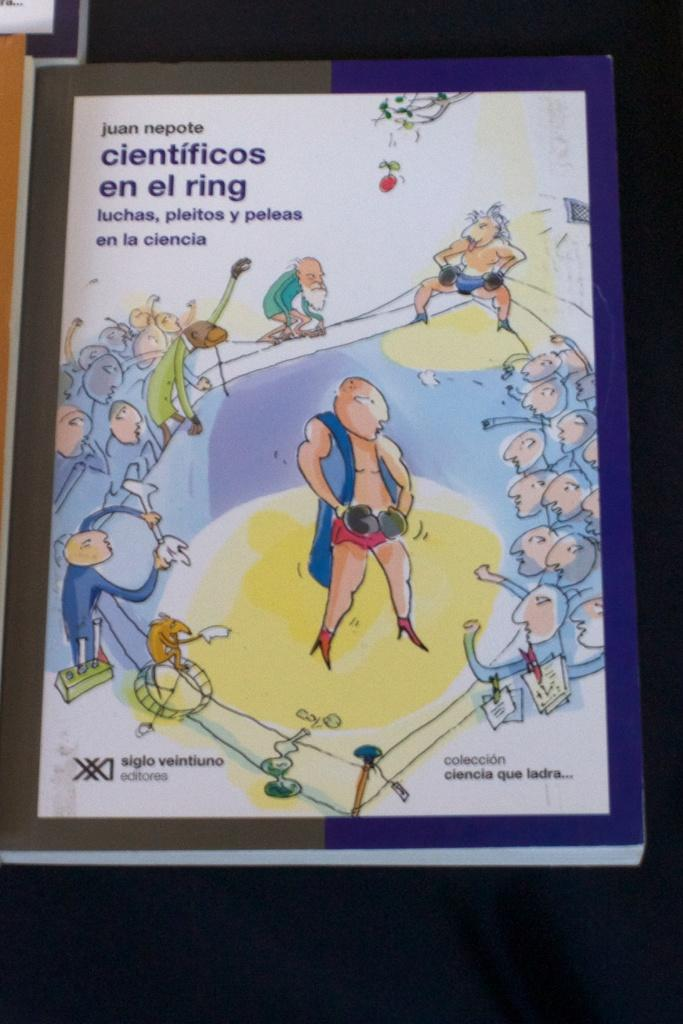What object is the main focus of the image? There is a book in the image. What can be seen on the book cover? The book cover has a man standing in the middle. What is the man wearing on his hands? The man is wearing gloves. What are the people around the man doing? These people are cheering. What type of skin is visible on the tent in the image? There is no tent present in the image; it features a book with a man on the cover. How many seats are available for the audience in the image? There is no reference to an audience or seats in the image; it only shows a book with a man on the cover. 